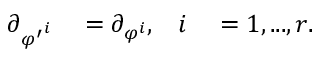Convert formula to latex. <formula><loc_0><loc_0><loc_500><loc_500>\begin{array} { r l r l } { \partial _ { { \varphi ^ { \prime } } ^ { i } } } & = \partial _ { \varphi ^ { i } } , } & { i } & = 1 , \dots , r . } \end{array}</formula> 